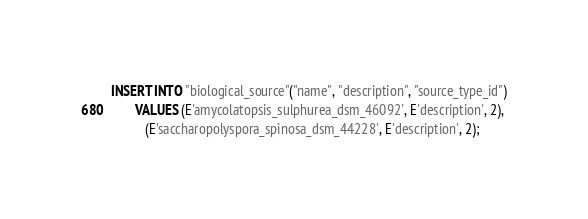<code> <loc_0><loc_0><loc_500><loc_500><_SQL_>INSERT INTO "biological_source"("name", "description", "source_type_id")
       VALUES (E'amycolatopsis_sulphurea_dsm_46092', E'description', 2),
	      (E'saccharopolyspora_spinosa_dsm_44228', E'description', 2);
</code> 